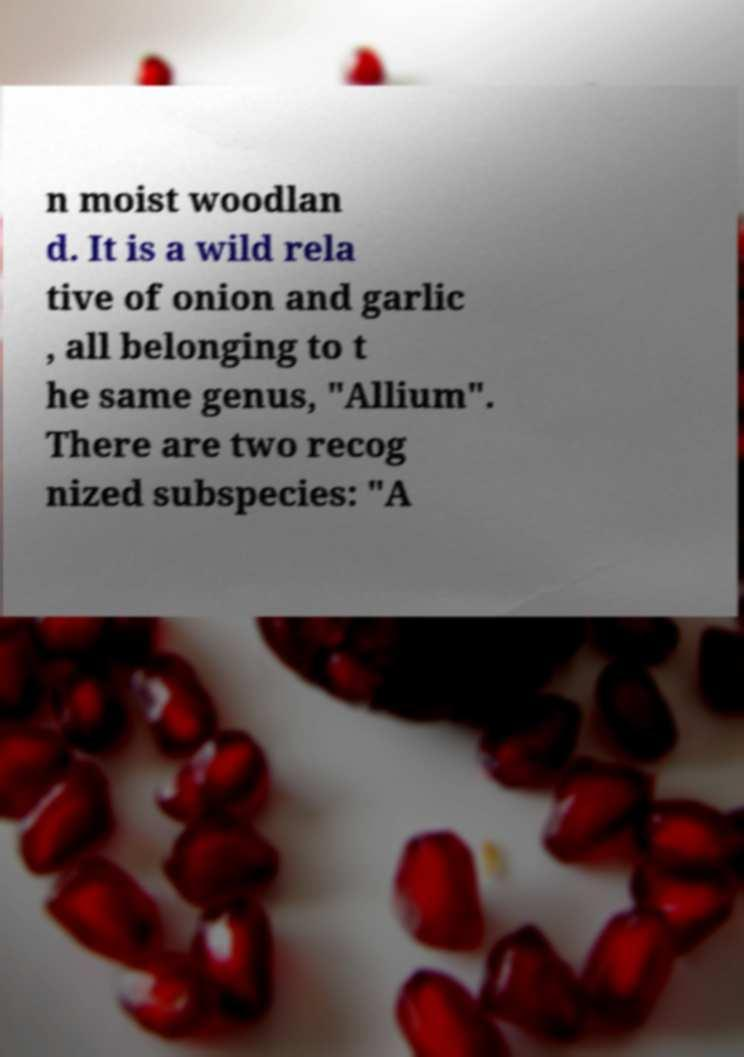What messages or text are displayed in this image? I need them in a readable, typed format. n moist woodlan d. It is a wild rela tive of onion and garlic , all belonging to t he same genus, "Allium". There are two recog nized subspecies: "A 